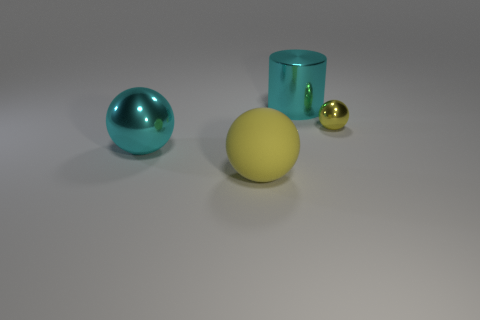Subtract all brown cylinders. How many yellow spheres are left? 2 Subtract all large spheres. How many spheres are left? 1 Subtract 1 balls. How many balls are left? 2 Add 3 tiny yellow things. How many objects exist? 7 Subtract all cylinders. How many objects are left? 3 Subtract all brown balls. Subtract all purple cylinders. How many balls are left? 3 Add 1 tiny brown things. How many tiny brown things exist? 1 Subtract 0 brown blocks. How many objects are left? 4 Subtract all brown metal spheres. Subtract all tiny metallic things. How many objects are left? 3 Add 4 cylinders. How many cylinders are left? 5 